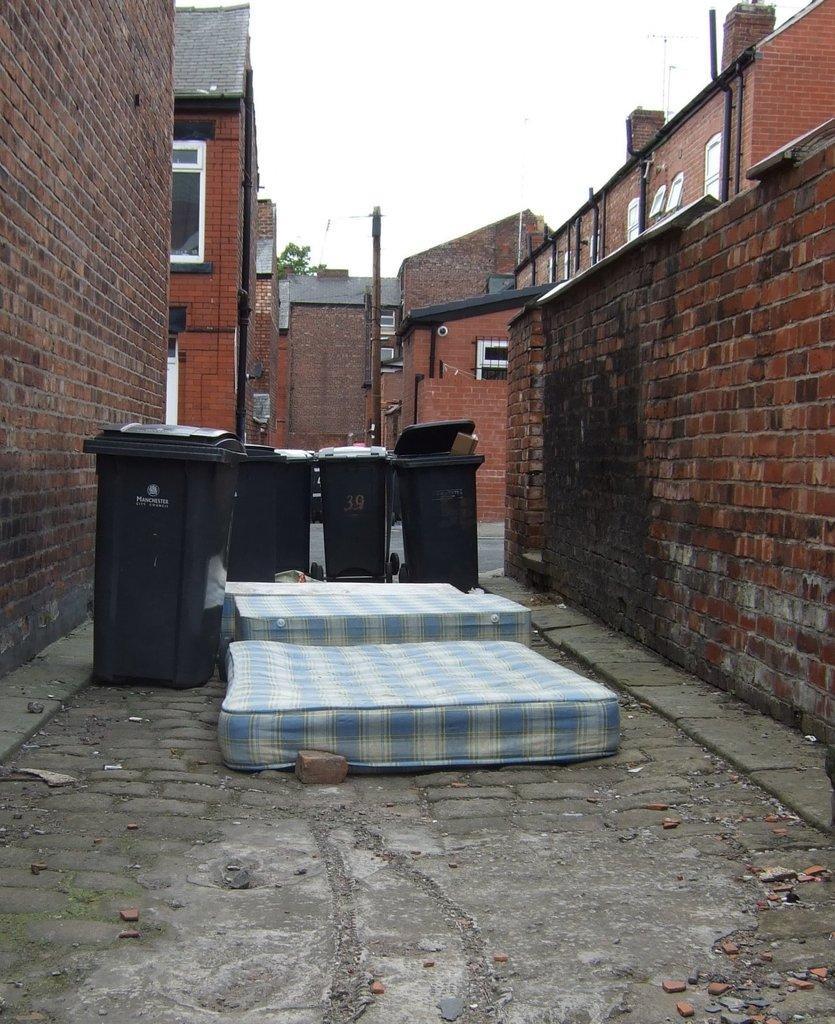In one or two sentences, can you explain what this image depicts? In this image we can see beds, dustbins, stones and brick are on the road. On the left and right side we can see the walls. In the background there are buildings, windows, poles, trees, road, objects and the sky. 